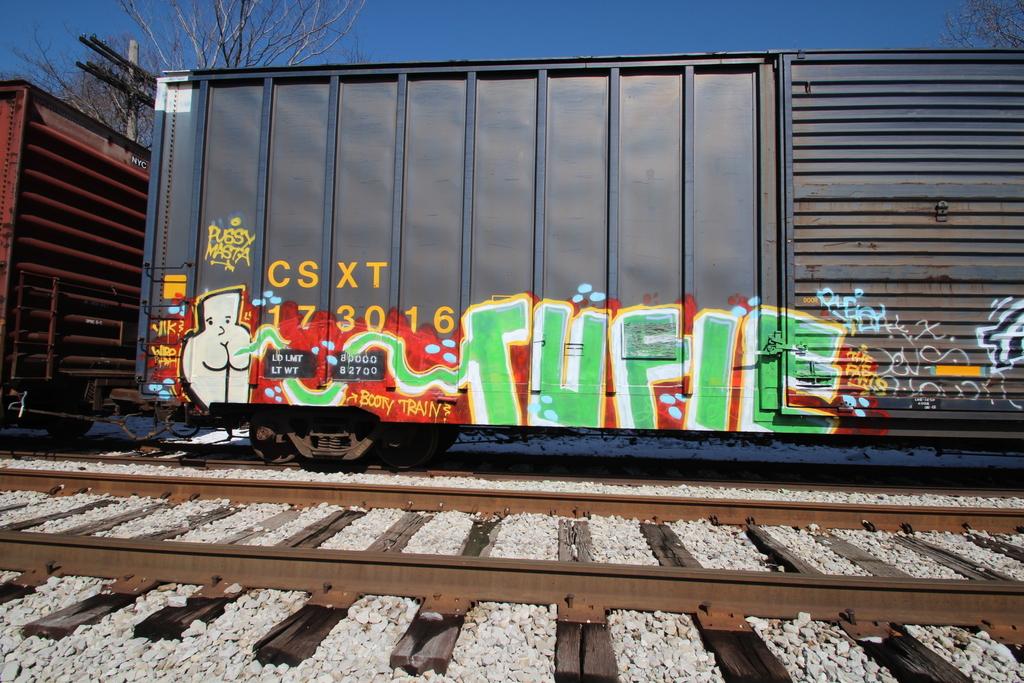Who manufactured the railroad car?
Provide a succinct answer. Csxt. What is the car number?
Provide a short and direct response. 173016. 